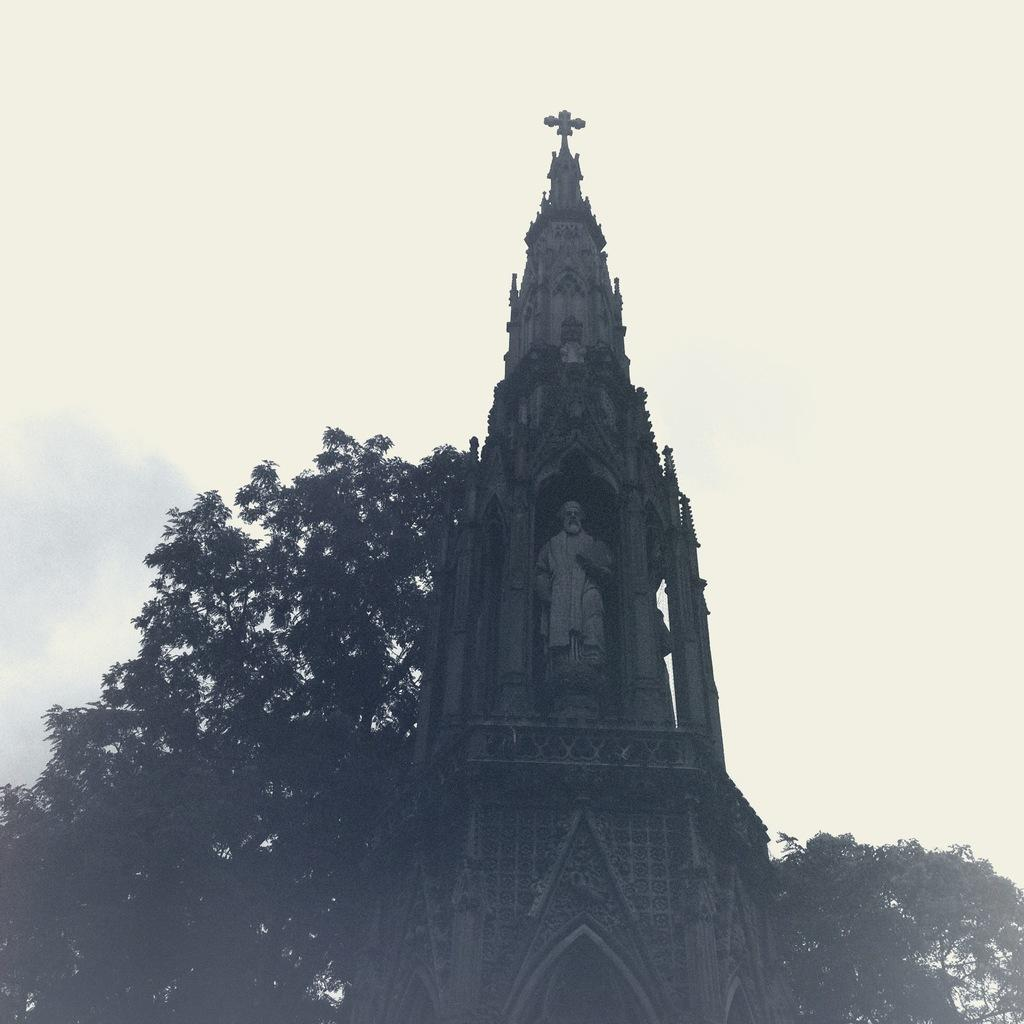What type of building is in the image? There is a church in the image. What other natural element is present in the image? There is a tree in the image. What can be seen in the sky in the image? The sky is visible in the image and appears to be clear. What type of silver is being displayed on the quilt in the image? There is no silver or quilt present in the image; it features a church and a tree. 